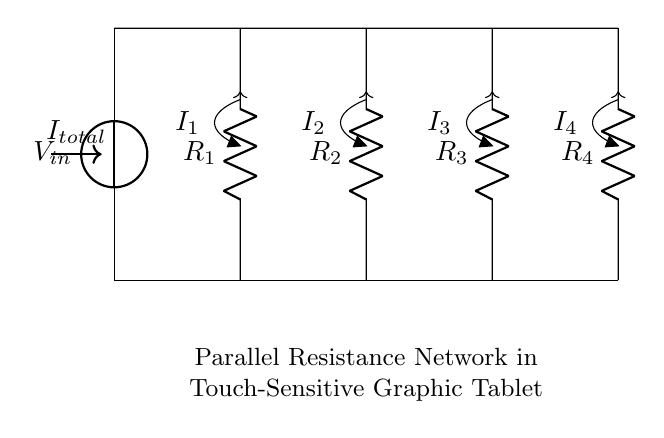What is the voltage across the input? The voltage across the input, labeled as V in the circuit, is applied between the top (positive) and bottom (negative) terminals of the circuit.
Answer: V How many resistors are in the circuit? Counting the labeled resistors (R1, R2, R3, R4) gives a total of four resistors.
Answer: 4 What type of circuit is this? The circuit is a parallel configuration of resistors, which is typical in current divider applications.
Answer: Parallel circuit Which resistor carries the highest current? In a current divider, the resistor with the lowest resistance will carry the highest current, which is R1, R2, R3, or R4 depending on their resistance values.
Answer: R1, R2, R3, or R4 What is the total current flowing into the circuit? The total current entering the circuit can be referred to as I total, indicating the sum of all the individual currents flowing through each resistor.
Answer: I total If all resistances are equal, what is the current through each resistor? In a current divider, if all resistors are equal, the total current is divided equally among them, resulting in each carrying one-fourth of the total current.
Answer: One-fourth of I total 